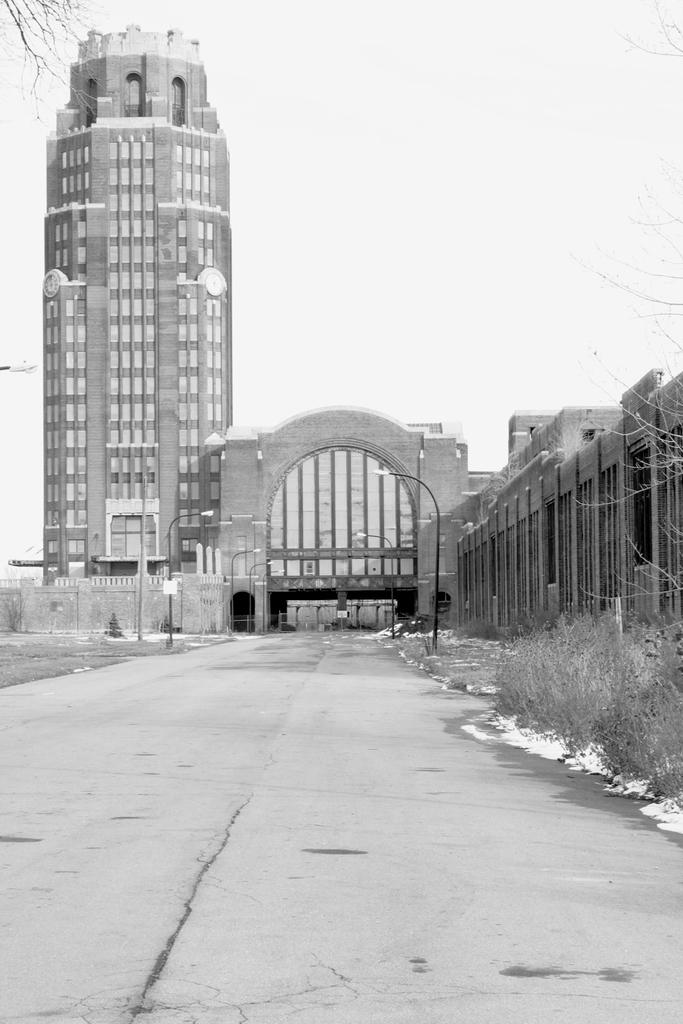What is the color scheme of the image? The image is black and white. What can be seen on the right side of the image? There are plants on the right side of the image. What is visible in the background of the image? There are buildings in the background of the image. How many planes can be seen flying in the image? There are no planes visible in the image, as it is a black and white image with plants on the right side and buildings in the background. 